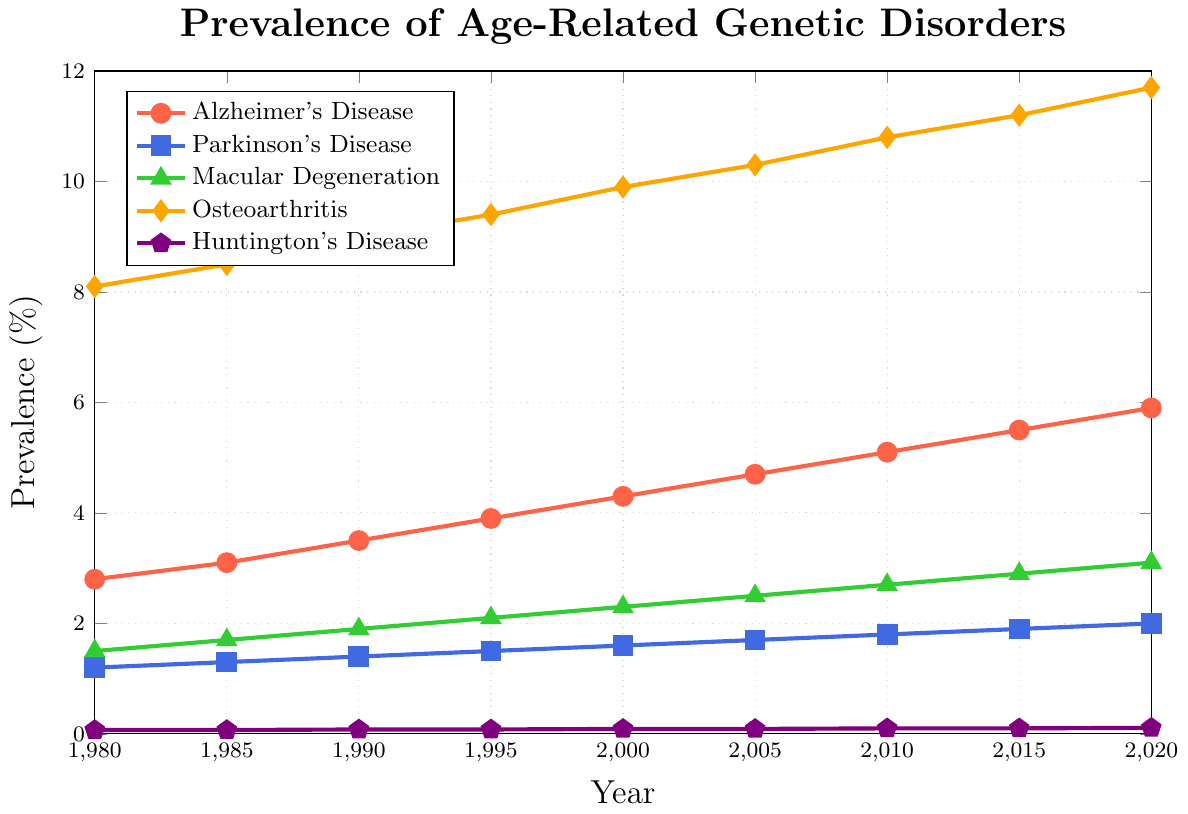What condition had the highest prevalence in 2020? By looking at the lines in the figure, we can observe which one reaches the highest value on the y-axis in the year 2020. The orange line representing Osteoarthritis is the highest in 2020.
Answer: Osteoarthritis Which condition had a lower prevalence in 1980, Alzheimer's Disease or Parkinson's Disease? By checking the values at the year 1980 in the figure, we see that Alzheimer's Disease is at 2.8% and Parkinson's Disease is at 1.2%. Therefore, Parkinson's Disease had a lower prevalence.
Answer: Parkinson's Disease Between which years did Macular Degeneration show the greatest increase in prevalence? To answer this, we need to compare the differences in prevalence of Macular Degeneration between consecutive years and identify the largest increment. The largest increase is between 2015 and 2020 (2.9% to 3.1%).
Answer: 2015-2020 How much did the prevalence of Alzheimer's Disease increase from 1980 to 2020? Subtract the value of Alzheimer's Disease in 1980 from its value in 2020. (5.9% - 2.8%)
Answer: 3.1% What was the combined prevalence of Osteoarthritis and Huntington's Disease in 2000? Add the prevalence values of Osteoarthritis and Huntington's Disease for the year 2000. (9.9% + 0.09%)
Answer: 9.99% Which disorder has consistently shown the least prevalence over the years? By observing the figure, Huntington's Disease has the lowest prevalence values across all years.
Answer: Huntington's Disease Between 1980 and 2020, which condition's prevalence increased the least? Calculate the increase in prevalence for each condition and compare them. Huntington's Disease increased from 0.07% to 0.11%, which is the smallest increase of 0.04%.
Answer: Huntington's Disease Order the conditions by their prevalence in the year 1995 from highest to lowest. Checking the values for each condition in 1995: Osteoarthritis (9.4%), Alzheimer's Disease (3.9%), Macular Degeneration (2.1%), Parkinson's Disease (1.5%), Huntington's Disease (0.08%).
Answer: Osteoarthritis, Alzheimer's Disease, Macular Degeneration, Parkinson's Disease, Huntington's Disease 